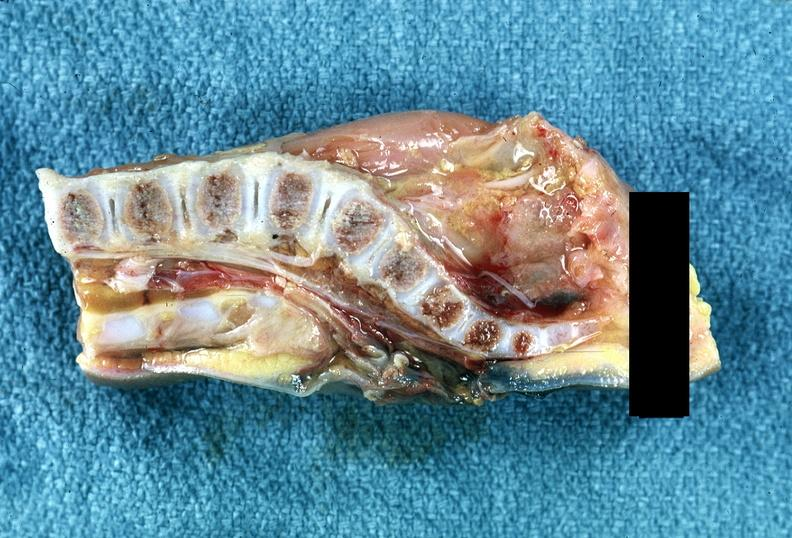does atheromatous embolus show neural tube defect?
Answer the question using a single word or phrase. No 